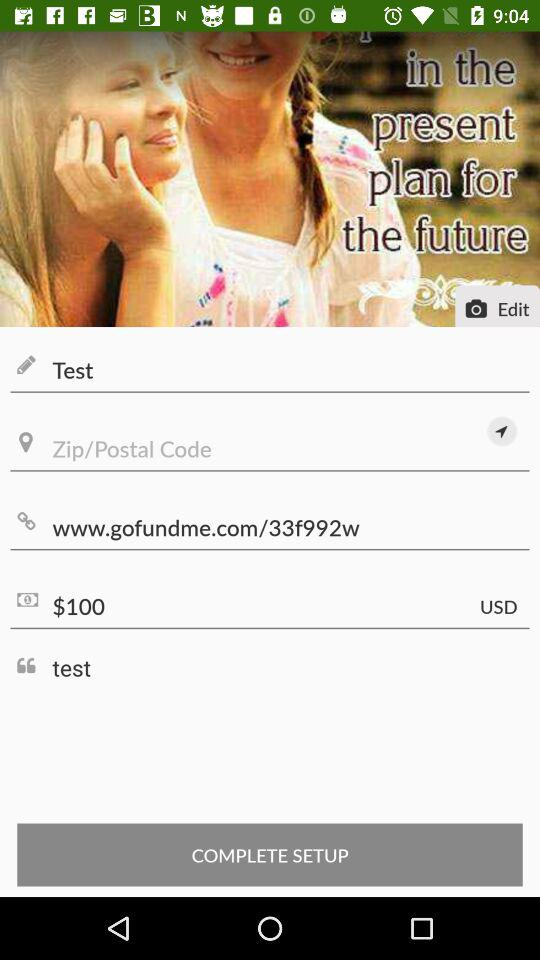What is the amount? The amount is 100 USD. 